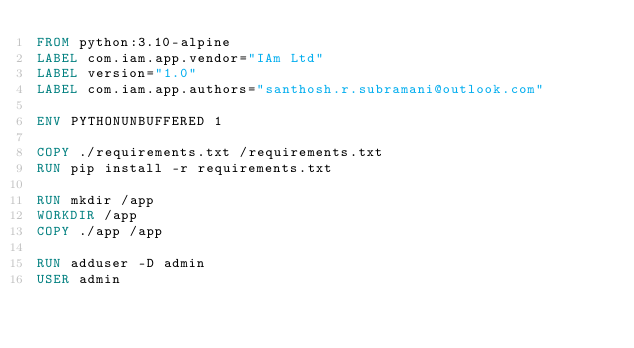<code> <loc_0><loc_0><loc_500><loc_500><_Dockerfile_>FROM python:3.10-alpine
LABEL com.iam.app.vendor="IAm Ltd"
LABEL version="1.0"
LABEL com.iam.app.authors="santhosh.r.subramani@outlook.com"

ENV PYTHONUNBUFFERED 1

COPY ./requirements.txt /requirements.txt
RUN pip install -r requirements.txt

RUN mkdir /app
WORKDIR /app
COPY ./app /app

RUN adduser -D admin
USER admin</code> 